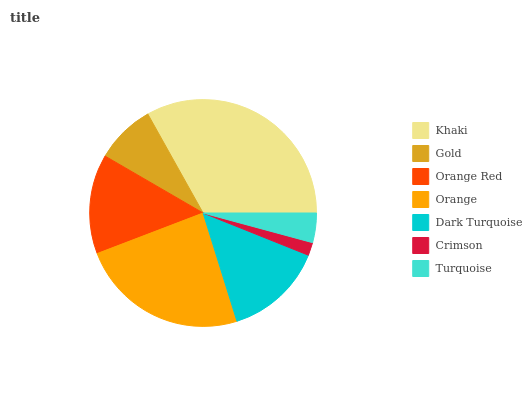Is Crimson the minimum?
Answer yes or no. Yes. Is Khaki the maximum?
Answer yes or no. Yes. Is Gold the minimum?
Answer yes or no. No. Is Gold the maximum?
Answer yes or no. No. Is Khaki greater than Gold?
Answer yes or no. Yes. Is Gold less than Khaki?
Answer yes or no. Yes. Is Gold greater than Khaki?
Answer yes or no. No. Is Khaki less than Gold?
Answer yes or no. No. Is Dark Turquoise the high median?
Answer yes or no. Yes. Is Dark Turquoise the low median?
Answer yes or no. Yes. Is Orange the high median?
Answer yes or no. No. Is Orange Red the low median?
Answer yes or no. No. 